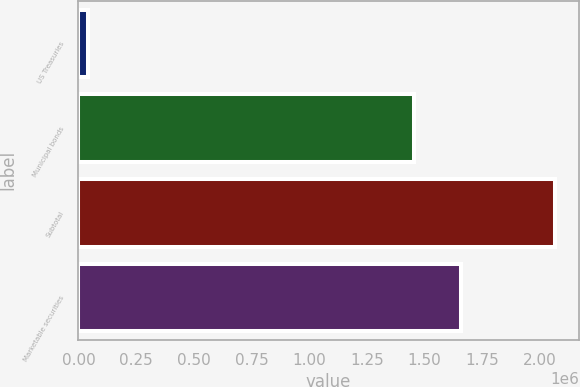Convert chart to OTSL. <chart><loc_0><loc_0><loc_500><loc_500><bar_chart><fcel>US Treasuries<fcel>Municipal bonds<fcel>Subtotal<fcel>Marketable securities<nl><fcel>42582<fcel>1.45585e+06<fcel>2.06524e+06<fcel>1.65811e+06<nl></chart> 